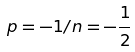<formula> <loc_0><loc_0><loc_500><loc_500>p = - 1 / n = - { \frac { 1 } { 2 } }</formula> 